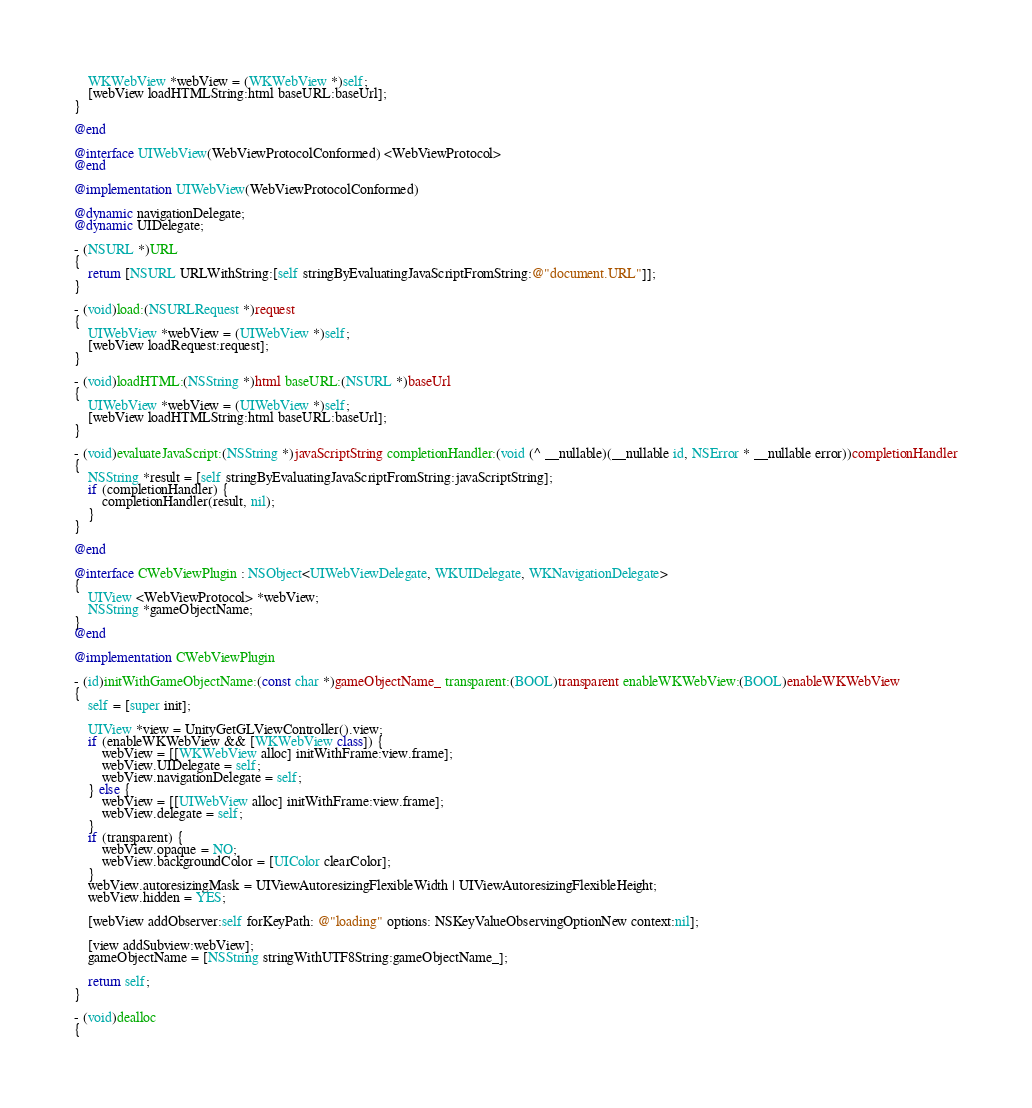Convert code to text. <code><loc_0><loc_0><loc_500><loc_500><_ObjectiveC_>    WKWebView *webView = (WKWebView *)self;
    [webView loadHTMLString:html baseURL:baseUrl];
}

@end

@interface UIWebView(WebViewProtocolConformed) <WebViewProtocol>
@end

@implementation UIWebView(WebViewProtocolConformed)

@dynamic navigationDelegate;
@dynamic UIDelegate;

- (NSURL *)URL
{
    return [NSURL URLWithString:[self stringByEvaluatingJavaScriptFromString:@"document.URL"]];
}

- (void)load:(NSURLRequest *)request
{
    UIWebView *webView = (UIWebView *)self;
    [webView loadRequest:request];
}

- (void)loadHTML:(NSString *)html baseURL:(NSURL *)baseUrl
{
    UIWebView *webView = (UIWebView *)self;
    [webView loadHTMLString:html baseURL:baseUrl];
}

- (void)evaluateJavaScript:(NSString *)javaScriptString completionHandler:(void (^ __nullable)(__nullable id, NSError * __nullable error))completionHandler
{
    NSString *result = [self stringByEvaluatingJavaScriptFromString:javaScriptString];
    if (completionHandler) {
        completionHandler(result, nil);
    }
}

@end

@interface CWebViewPlugin : NSObject<UIWebViewDelegate, WKUIDelegate, WKNavigationDelegate>
{
    UIView <WebViewProtocol> *webView;
    NSString *gameObjectName;
}
@end

@implementation CWebViewPlugin

- (id)initWithGameObjectName:(const char *)gameObjectName_ transparent:(BOOL)transparent enableWKWebView:(BOOL)enableWKWebView
{
    self = [super init];

    UIView *view = UnityGetGLViewController().view;
    if (enableWKWebView && [WKWebView class]) {
        webView = [[WKWebView alloc] initWithFrame:view.frame];
        webView.UIDelegate = self;
        webView.navigationDelegate = self;
    } else {
        webView = [[UIWebView alloc] initWithFrame:view.frame];
        webView.delegate = self;
    }
    if (transparent) {
        webView.opaque = NO;
        webView.backgroundColor = [UIColor clearColor];
    }
    webView.autoresizingMask = UIViewAutoresizingFlexibleWidth | UIViewAutoresizingFlexibleHeight;
    webView.hidden = YES;
    
    [webView addObserver:self forKeyPath: @"loading" options: NSKeyValueObservingOptionNew context:nil];
    
    [view addSubview:webView];
    gameObjectName = [NSString stringWithUTF8String:gameObjectName_];
    
    return self;
}

- (void)dealloc
{</code> 